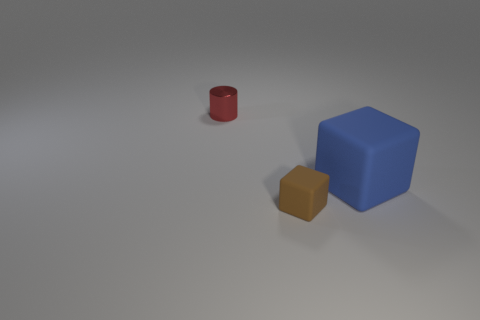Add 2 large red rubber cylinders. How many objects exist? 5 Subtract all cylinders. How many objects are left? 2 Add 1 red shiny cylinders. How many red shiny cylinders are left? 2 Add 1 small red matte cylinders. How many small red matte cylinders exist? 1 Subtract 0 yellow balls. How many objects are left? 3 Subtract all small cyan cylinders. Subtract all big rubber objects. How many objects are left? 2 